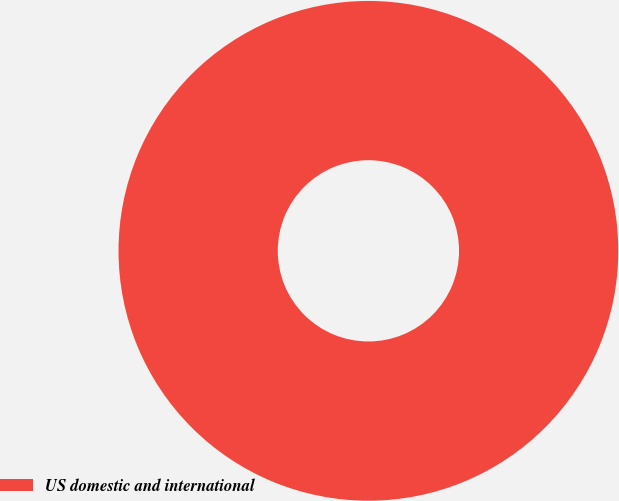Convert chart to OTSL. <chart><loc_0><loc_0><loc_500><loc_500><pie_chart><fcel>US domestic and international<nl><fcel>100.0%<nl></chart> 